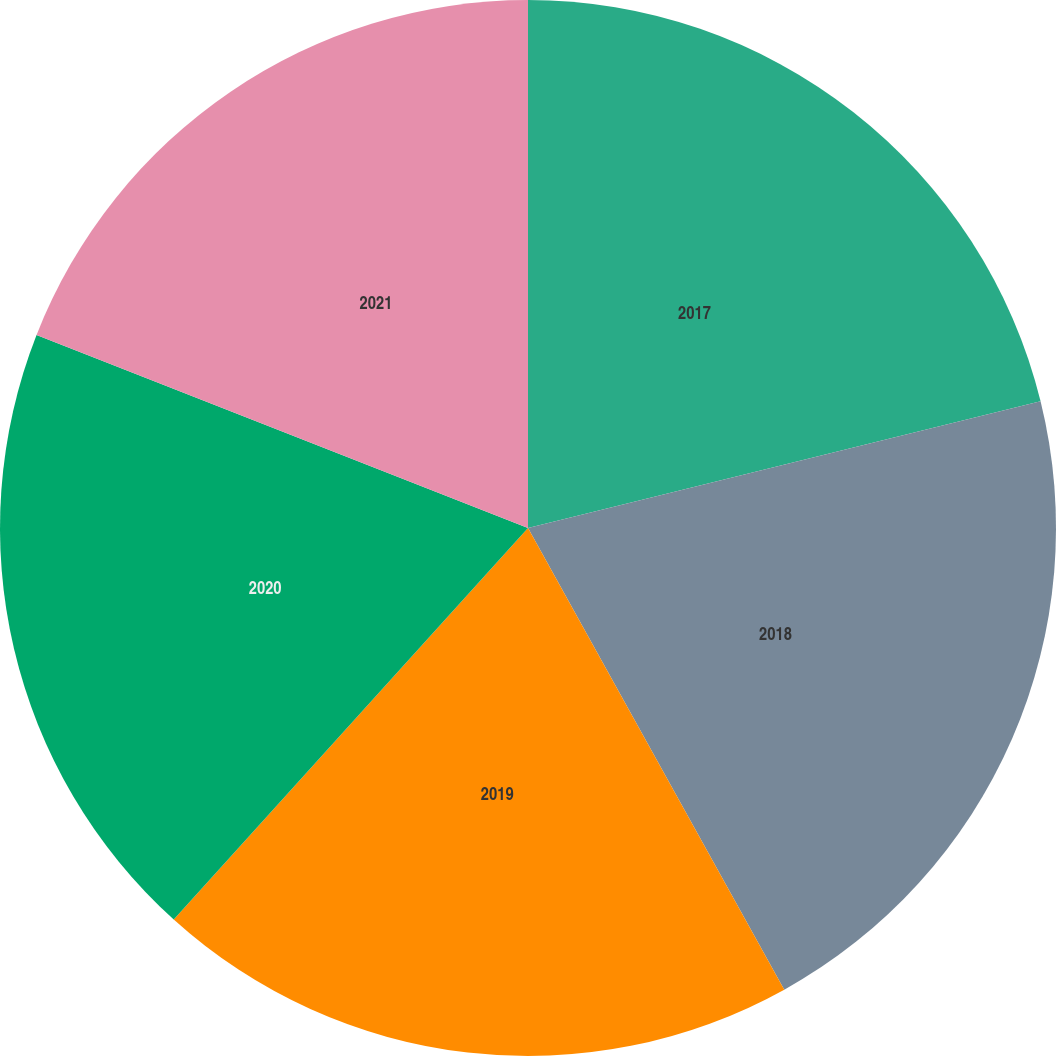Convert chart to OTSL. <chart><loc_0><loc_0><loc_500><loc_500><pie_chart><fcel>2017<fcel>2018<fcel>2019<fcel>2020<fcel>2021<nl><fcel>21.14%<fcel>20.79%<fcel>19.77%<fcel>19.25%<fcel>19.04%<nl></chart> 